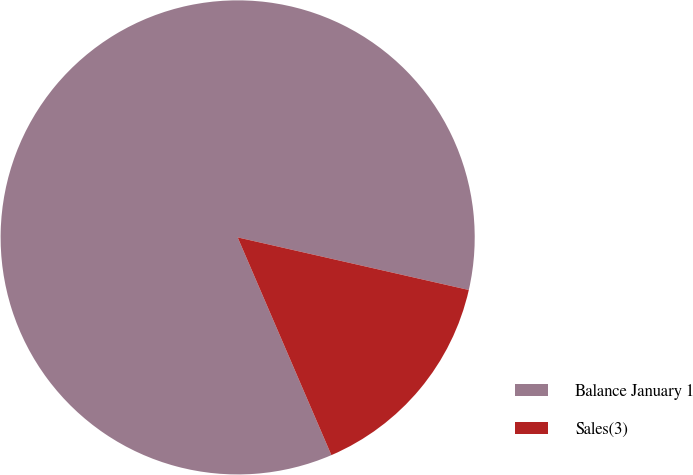Convert chart. <chart><loc_0><loc_0><loc_500><loc_500><pie_chart><fcel>Balance January 1<fcel>Sales(3)<nl><fcel>85.03%<fcel>14.97%<nl></chart> 